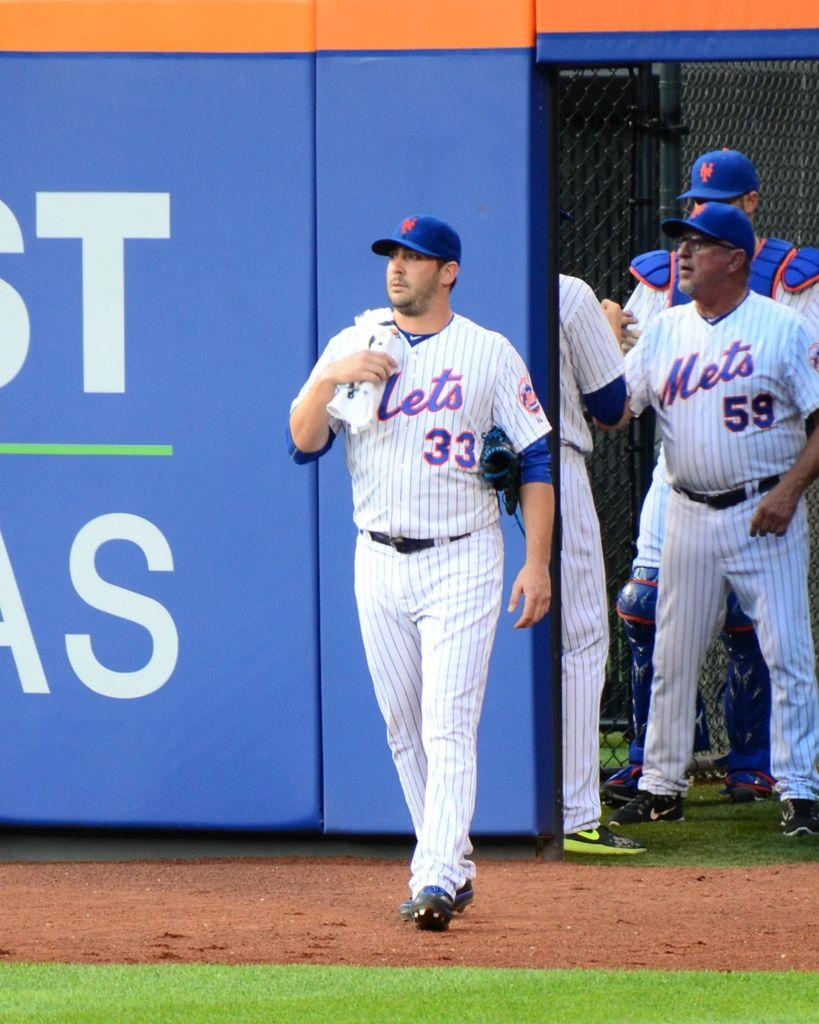<image>
Share a concise interpretation of the image provided. A Mets baseball player is walking out to the field. 